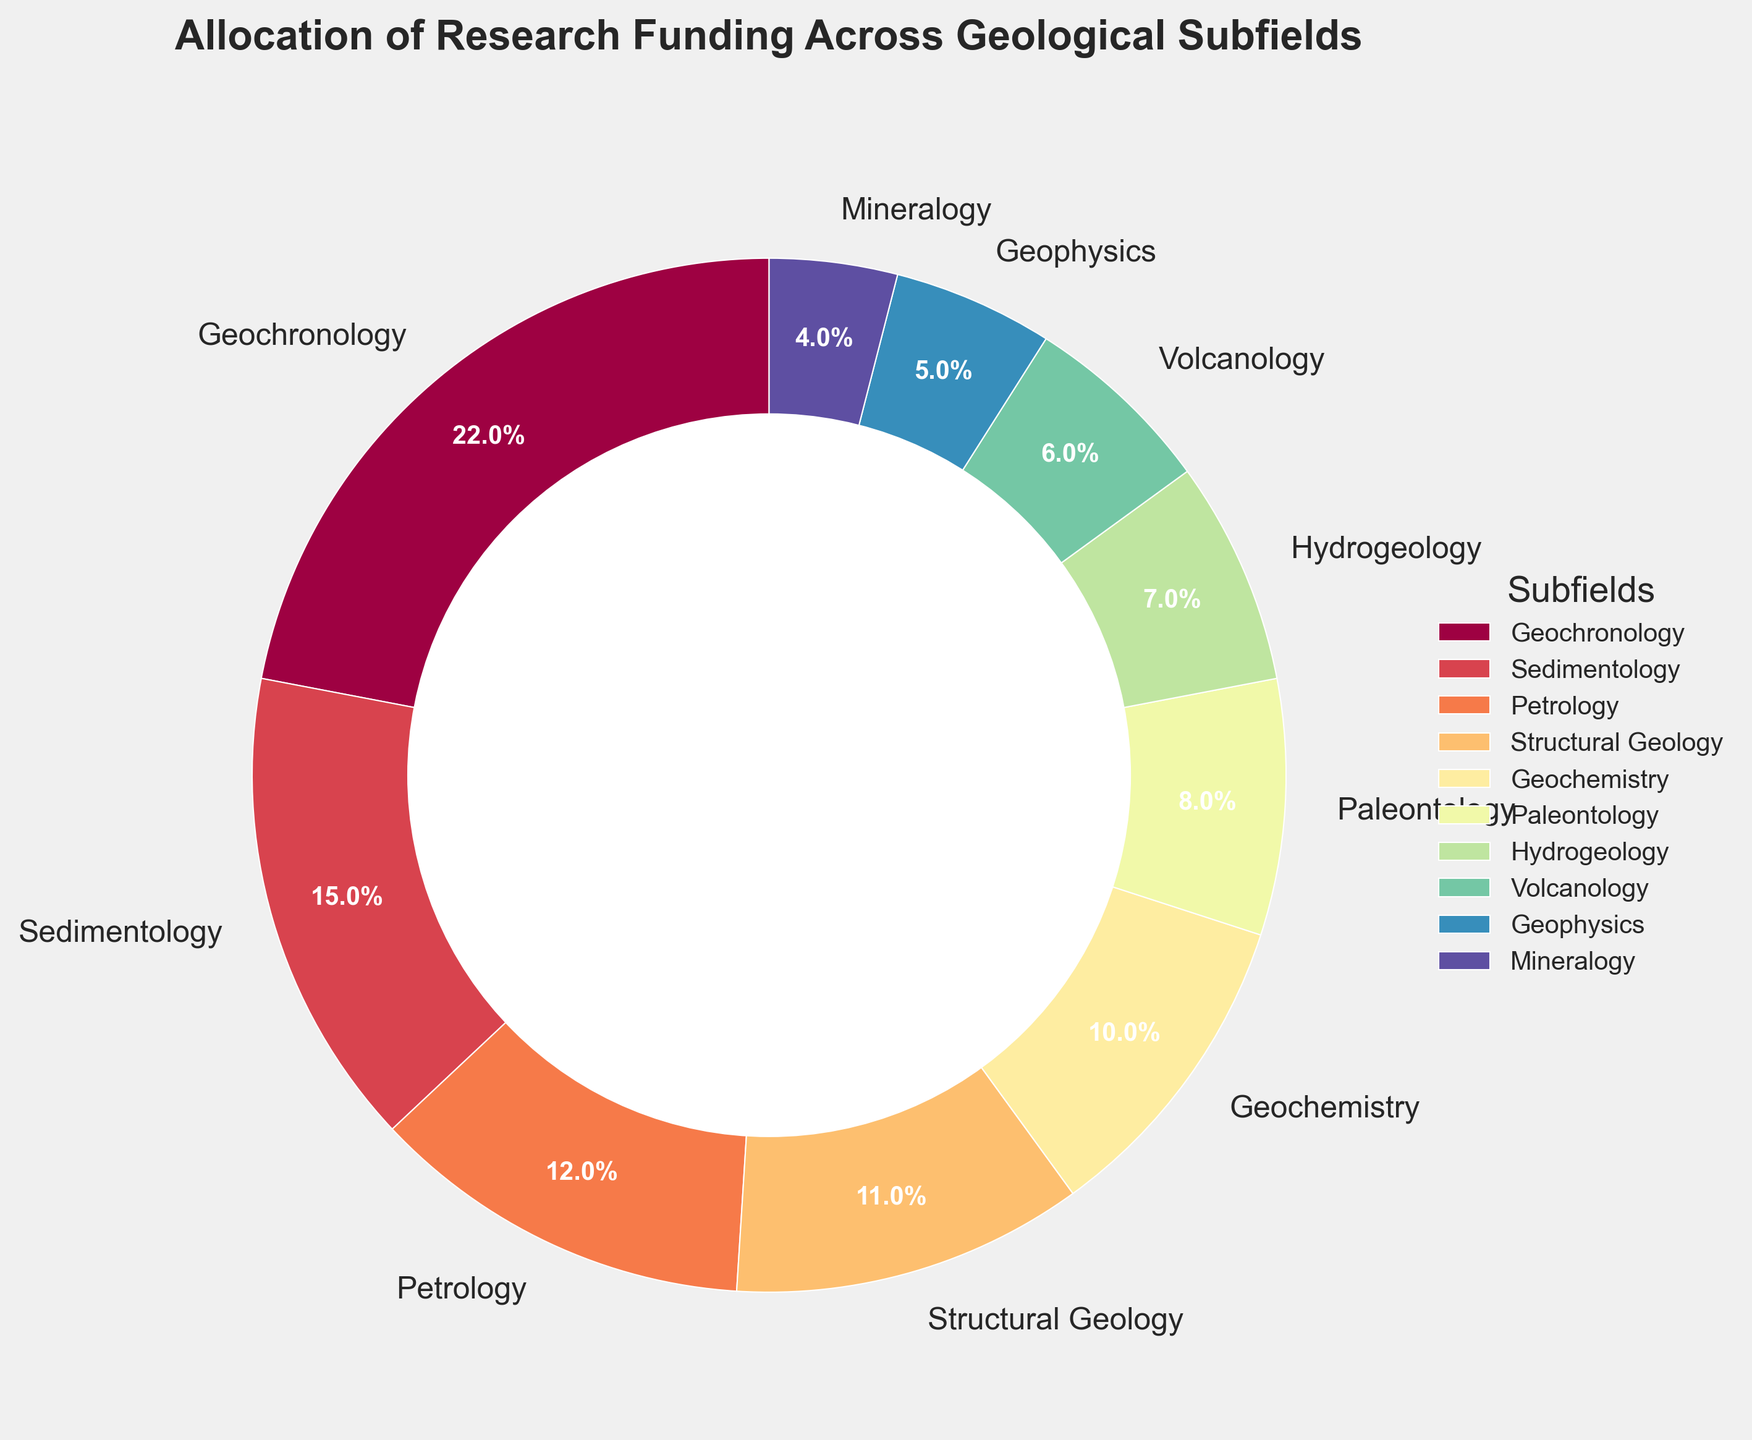What subfield receives the highest percentage of research funding? The largest wedge in the pie chart represents the subfield with the highest percentage of research funding. Geochronology has the largest wedge and is labeled with 22%.
Answer: Geochronology (22%) What is the total funding percentage for Geochronology and Sedimentology combined? Identify the percentages of Geochronology and Sedimentology on the pie chart (22% and 15% respectively). Sum these percentages: 22% + 15% = 37%.
Answer: 37% Which subfield receives less funding: Hydrogeology or Volcanology? Compare the wedges' sizes representing Hydrogeology and Volcanology. Hydrogeology has 7%, while Volcanology has 6%. Volcanology has a smaller wedge.
Answer: Volcanology (6%) How much more funding does Petrology receive compared to Mineralogy? Identify the percentages for Petrology and Mineralogy on the pie chart (12% for Petrology and 4% for Mineralogy). Subtract the smaller percentage from the larger percentage: 12% - 4% = 8%.
Answer: 8% What is the average funding percentage for the subfields that receive at least 10% of the funding? Identify the subfields with at least 10% funding each: Geochronology (22%), Sedimentology (15%), Petrology (12%), and Structural Geology (11%). Sum these percentages: 22% + 15% + 12% + 11% = 60%. Divide by the number of subfields: 60% / 4 = 15%.
Answer: 15% Which subfield receives just slightly more funding than Structural Geology? Identify the percentage of Structural Geology (11%) and look for the immediately higher percentage on the pie chart. Petrology has 12%, which is the next highest.
Answer: Petrology (12%) What is the visual difference between the area representing Geophysics and the area representing Mineralogy? Compare the wedges on the pie chart labeled Geophysics (5%) and Mineralogy (4%). The wedge for Geophysics is slightly larger than the wedge for Mineralogy.
Answer: Geophysics has a larger wedge Is the sum of funding percentages for Paleontology and Geophysics greater than 15%? Identify the percentages for Paleontology and Geophysics (8% and 5% respectively). Sum these percentages: 8% + 5% = 13%, which is less than 15%.
Answer: No Which subfield has the smallest wedge, and what percentage does it represent? The smallest wedge on the pie chart belongs to Mineralogy, representing 4%.
Answer: Mineralogy (4%) If the funding for each subfield were to be doubled, what would be the new percentage for Volcanology? The initial percentage for Volcanology is 6%. Doubling this: 6% × 2 = 12%.
Answer: 12% 